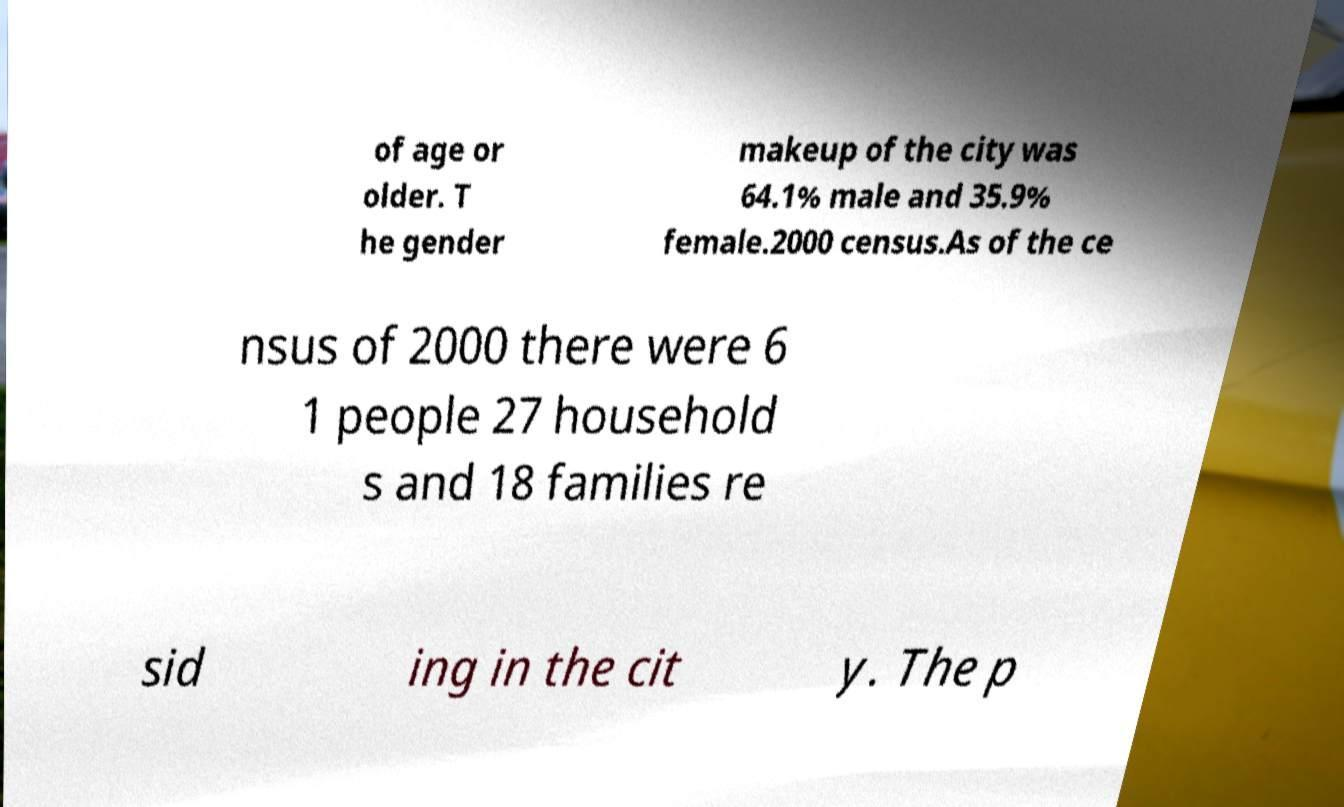Can you accurately transcribe the text from the provided image for me? of age or older. T he gender makeup of the city was 64.1% male and 35.9% female.2000 census.As of the ce nsus of 2000 there were 6 1 people 27 household s and 18 families re sid ing in the cit y. The p 